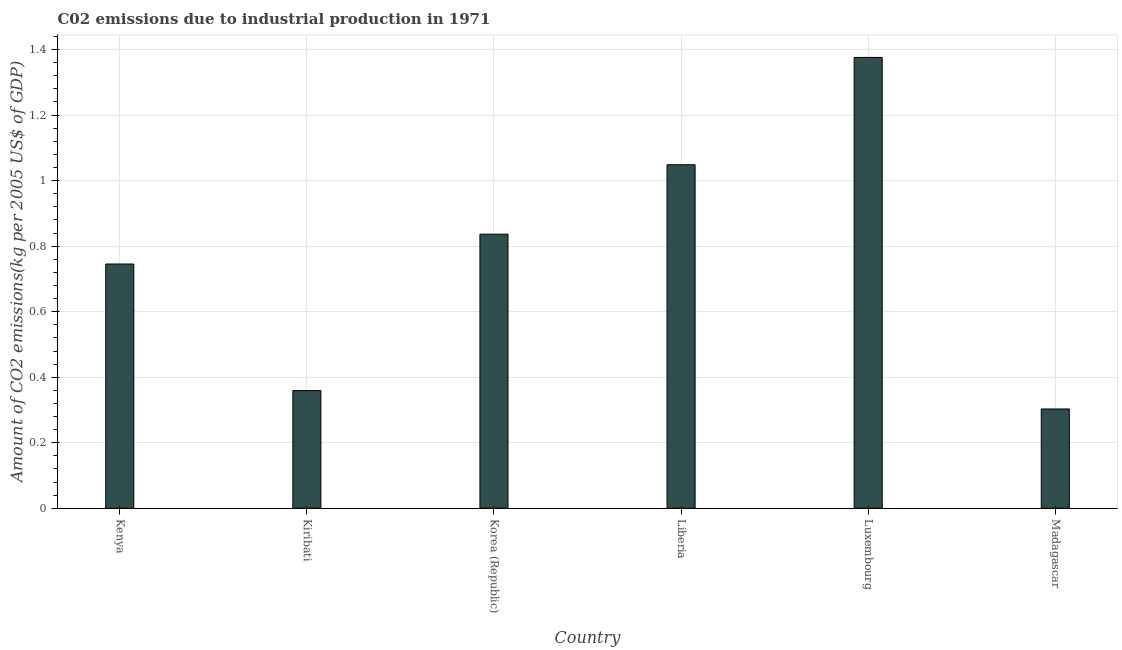Does the graph contain any zero values?
Provide a short and direct response. No. Does the graph contain grids?
Your response must be concise. Yes. What is the title of the graph?
Offer a terse response. C02 emissions due to industrial production in 1971. What is the label or title of the Y-axis?
Your answer should be compact. Amount of CO2 emissions(kg per 2005 US$ of GDP). What is the amount of co2 emissions in Kenya?
Give a very brief answer. 0.75. Across all countries, what is the maximum amount of co2 emissions?
Offer a very short reply. 1.38. Across all countries, what is the minimum amount of co2 emissions?
Keep it short and to the point. 0.3. In which country was the amount of co2 emissions maximum?
Your answer should be very brief. Luxembourg. In which country was the amount of co2 emissions minimum?
Provide a succinct answer. Madagascar. What is the sum of the amount of co2 emissions?
Offer a very short reply. 4.67. What is the difference between the amount of co2 emissions in Kenya and Kiribati?
Ensure brevity in your answer.  0.39. What is the average amount of co2 emissions per country?
Your answer should be very brief. 0.78. What is the median amount of co2 emissions?
Keep it short and to the point. 0.79. What is the ratio of the amount of co2 emissions in Kenya to that in Luxembourg?
Offer a very short reply. 0.54. Is the difference between the amount of co2 emissions in Kiribati and Korea (Republic) greater than the difference between any two countries?
Offer a very short reply. No. What is the difference between the highest and the second highest amount of co2 emissions?
Provide a succinct answer. 0.33. Is the sum of the amount of co2 emissions in Kenya and Madagascar greater than the maximum amount of co2 emissions across all countries?
Provide a succinct answer. No. What is the difference between the highest and the lowest amount of co2 emissions?
Provide a short and direct response. 1.07. In how many countries, is the amount of co2 emissions greater than the average amount of co2 emissions taken over all countries?
Give a very brief answer. 3. Are all the bars in the graph horizontal?
Your answer should be compact. No. Are the values on the major ticks of Y-axis written in scientific E-notation?
Give a very brief answer. No. What is the Amount of CO2 emissions(kg per 2005 US$ of GDP) in Kenya?
Ensure brevity in your answer.  0.75. What is the Amount of CO2 emissions(kg per 2005 US$ of GDP) of Kiribati?
Your answer should be very brief. 0.36. What is the Amount of CO2 emissions(kg per 2005 US$ of GDP) in Korea (Republic)?
Offer a very short reply. 0.84. What is the Amount of CO2 emissions(kg per 2005 US$ of GDP) of Liberia?
Your answer should be very brief. 1.05. What is the Amount of CO2 emissions(kg per 2005 US$ of GDP) in Luxembourg?
Ensure brevity in your answer.  1.38. What is the Amount of CO2 emissions(kg per 2005 US$ of GDP) of Madagascar?
Give a very brief answer. 0.3. What is the difference between the Amount of CO2 emissions(kg per 2005 US$ of GDP) in Kenya and Kiribati?
Your answer should be very brief. 0.39. What is the difference between the Amount of CO2 emissions(kg per 2005 US$ of GDP) in Kenya and Korea (Republic)?
Provide a succinct answer. -0.09. What is the difference between the Amount of CO2 emissions(kg per 2005 US$ of GDP) in Kenya and Liberia?
Your answer should be compact. -0.3. What is the difference between the Amount of CO2 emissions(kg per 2005 US$ of GDP) in Kenya and Luxembourg?
Your answer should be very brief. -0.63. What is the difference between the Amount of CO2 emissions(kg per 2005 US$ of GDP) in Kenya and Madagascar?
Your response must be concise. 0.44. What is the difference between the Amount of CO2 emissions(kg per 2005 US$ of GDP) in Kiribati and Korea (Republic)?
Provide a short and direct response. -0.48. What is the difference between the Amount of CO2 emissions(kg per 2005 US$ of GDP) in Kiribati and Liberia?
Offer a terse response. -0.69. What is the difference between the Amount of CO2 emissions(kg per 2005 US$ of GDP) in Kiribati and Luxembourg?
Give a very brief answer. -1.02. What is the difference between the Amount of CO2 emissions(kg per 2005 US$ of GDP) in Kiribati and Madagascar?
Provide a short and direct response. 0.06. What is the difference between the Amount of CO2 emissions(kg per 2005 US$ of GDP) in Korea (Republic) and Liberia?
Keep it short and to the point. -0.21. What is the difference between the Amount of CO2 emissions(kg per 2005 US$ of GDP) in Korea (Republic) and Luxembourg?
Offer a very short reply. -0.54. What is the difference between the Amount of CO2 emissions(kg per 2005 US$ of GDP) in Korea (Republic) and Madagascar?
Give a very brief answer. 0.53. What is the difference between the Amount of CO2 emissions(kg per 2005 US$ of GDP) in Liberia and Luxembourg?
Make the answer very short. -0.33. What is the difference between the Amount of CO2 emissions(kg per 2005 US$ of GDP) in Liberia and Madagascar?
Provide a short and direct response. 0.75. What is the difference between the Amount of CO2 emissions(kg per 2005 US$ of GDP) in Luxembourg and Madagascar?
Offer a terse response. 1.07. What is the ratio of the Amount of CO2 emissions(kg per 2005 US$ of GDP) in Kenya to that in Kiribati?
Make the answer very short. 2.08. What is the ratio of the Amount of CO2 emissions(kg per 2005 US$ of GDP) in Kenya to that in Korea (Republic)?
Keep it short and to the point. 0.89. What is the ratio of the Amount of CO2 emissions(kg per 2005 US$ of GDP) in Kenya to that in Liberia?
Make the answer very short. 0.71. What is the ratio of the Amount of CO2 emissions(kg per 2005 US$ of GDP) in Kenya to that in Luxembourg?
Provide a succinct answer. 0.54. What is the ratio of the Amount of CO2 emissions(kg per 2005 US$ of GDP) in Kenya to that in Madagascar?
Give a very brief answer. 2.46. What is the ratio of the Amount of CO2 emissions(kg per 2005 US$ of GDP) in Kiribati to that in Korea (Republic)?
Your response must be concise. 0.43. What is the ratio of the Amount of CO2 emissions(kg per 2005 US$ of GDP) in Kiribati to that in Liberia?
Provide a succinct answer. 0.34. What is the ratio of the Amount of CO2 emissions(kg per 2005 US$ of GDP) in Kiribati to that in Luxembourg?
Make the answer very short. 0.26. What is the ratio of the Amount of CO2 emissions(kg per 2005 US$ of GDP) in Kiribati to that in Madagascar?
Keep it short and to the point. 1.19. What is the ratio of the Amount of CO2 emissions(kg per 2005 US$ of GDP) in Korea (Republic) to that in Liberia?
Provide a short and direct response. 0.8. What is the ratio of the Amount of CO2 emissions(kg per 2005 US$ of GDP) in Korea (Republic) to that in Luxembourg?
Provide a succinct answer. 0.61. What is the ratio of the Amount of CO2 emissions(kg per 2005 US$ of GDP) in Korea (Republic) to that in Madagascar?
Make the answer very short. 2.76. What is the ratio of the Amount of CO2 emissions(kg per 2005 US$ of GDP) in Liberia to that in Luxembourg?
Offer a terse response. 0.76. What is the ratio of the Amount of CO2 emissions(kg per 2005 US$ of GDP) in Liberia to that in Madagascar?
Your answer should be compact. 3.46. What is the ratio of the Amount of CO2 emissions(kg per 2005 US$ of GDP) in Luxembourg to that in Madagascar?
Your answer should be compact. 4.54. 